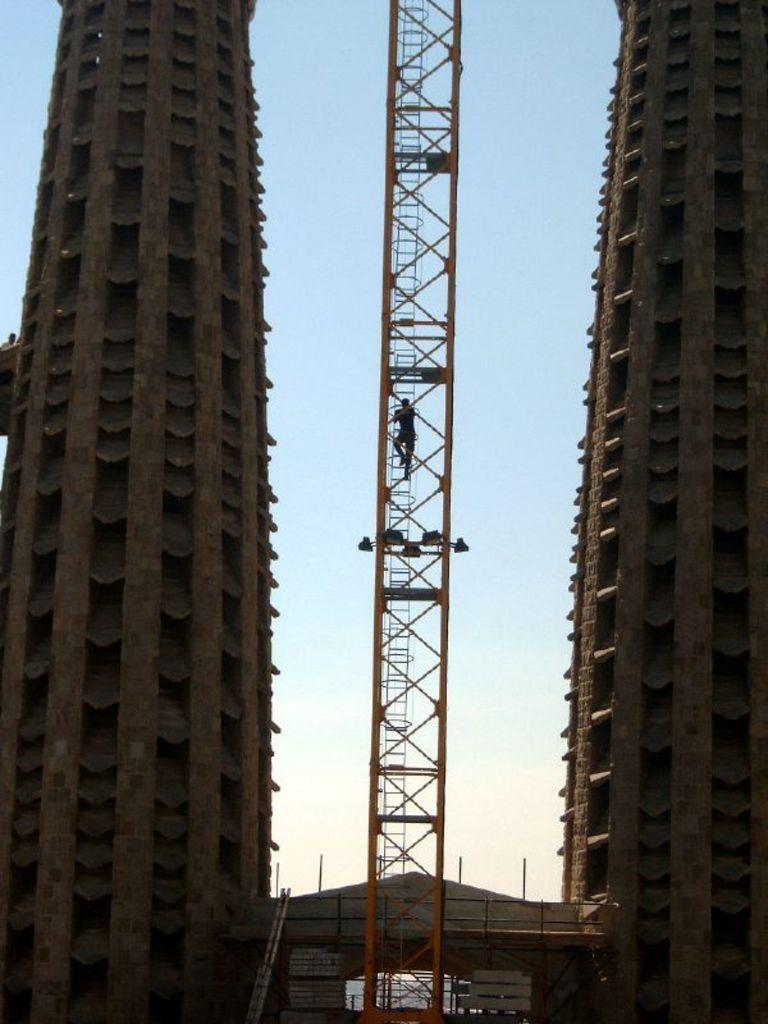How many buildings can be seen in the image? There are two buildings in the image. What is present in the image besides the buildings? There is an iron ladder and a person climbing the ladder in the image. What is the person doing in the image? The person is climbing the ladder. What can be seen in the background of the image? The sky is visible in the background of the image. What type of soup is being served in the image? There is no soup present in the image. Can you see any eggs in the image? There are no eggs visible in the image. 